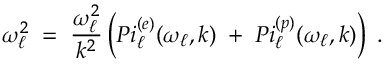Convert formula to latex. <formula><loc_0><loc_0><loc_500><loc_500>{ \omega _ { \ell } ^ { 2 } \, = \, { \frac { \omega _ { \ell } ^ { 2 } } { k ^ { 2 } } } \left ( P i _ { \ell } ^ { ( e ) } ( \omega _ { \ell } , k ) \, + \, P i _ { \ell } ^ { ( p ) } ( \omega _ { \ell } , k ) \right ) \, . }</formula> 